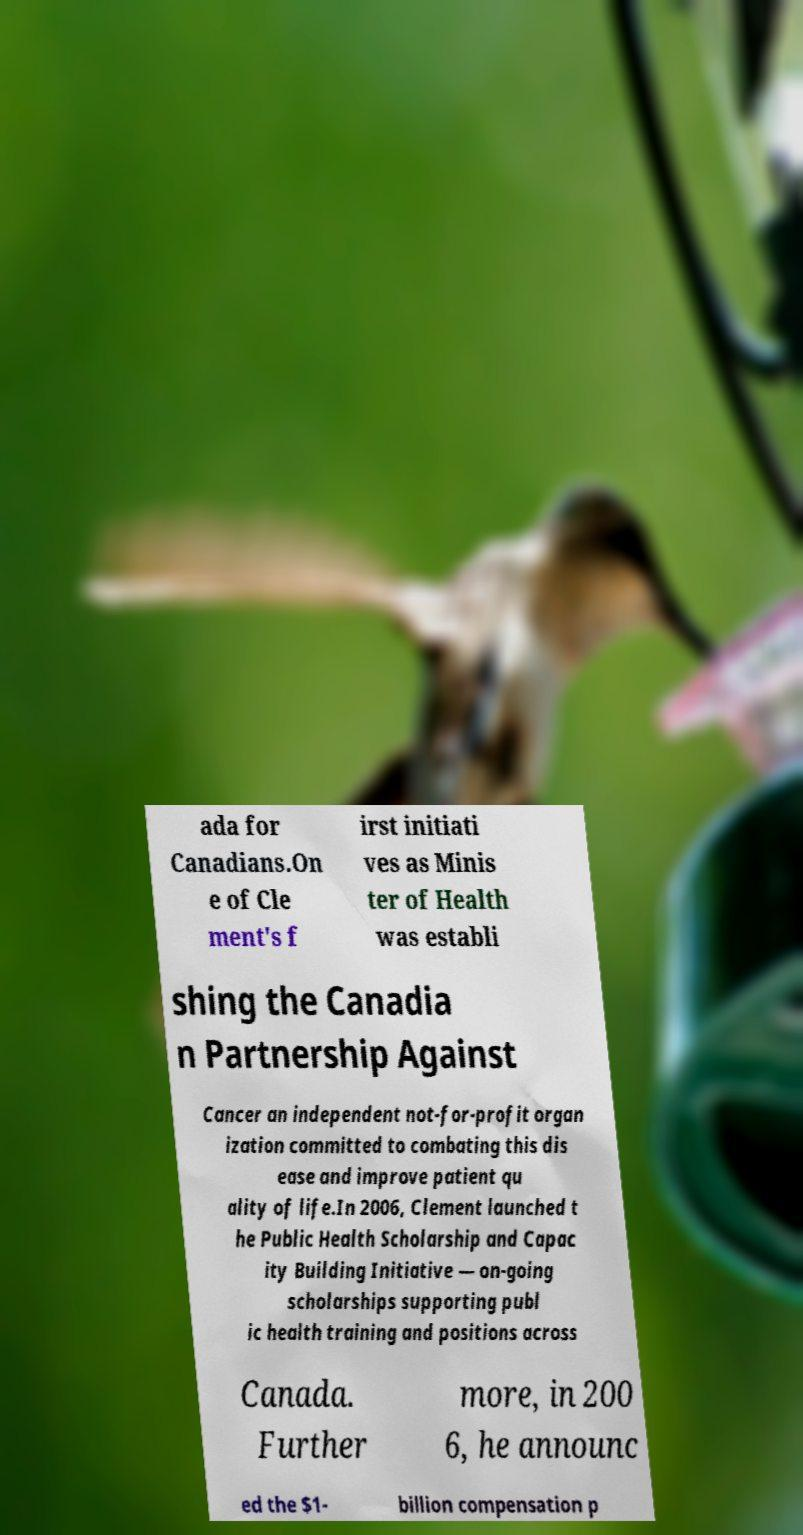Can you accurately transcribe the text from the provided image for me? ada for Canadians.On e of Cle ment's f irst initiati ves as Minis ter of Health was establi shing the Canadia n Partnership Against Cancer an independent not-for-profit organ ization committed to combating this dis ease and improve patient qu ality of life.In 2006, Clement launched t he Public Health Scholarship and Capac ity Building Initiative — on-going scholarships supporting publ ic health training and positions across Canada. Further more, in 200 6, he announc ed the $1- billion compensation p 